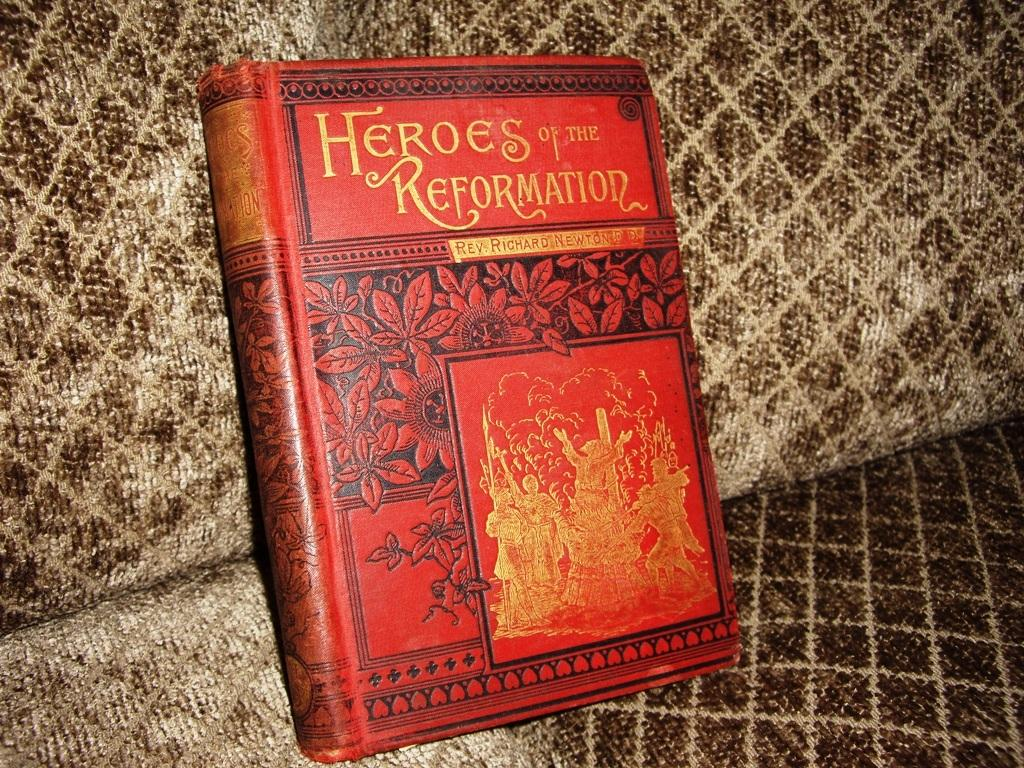<image>
Create a compact narrative representing the image presented. A red book about a legacy of heroes is on a brown couch. 